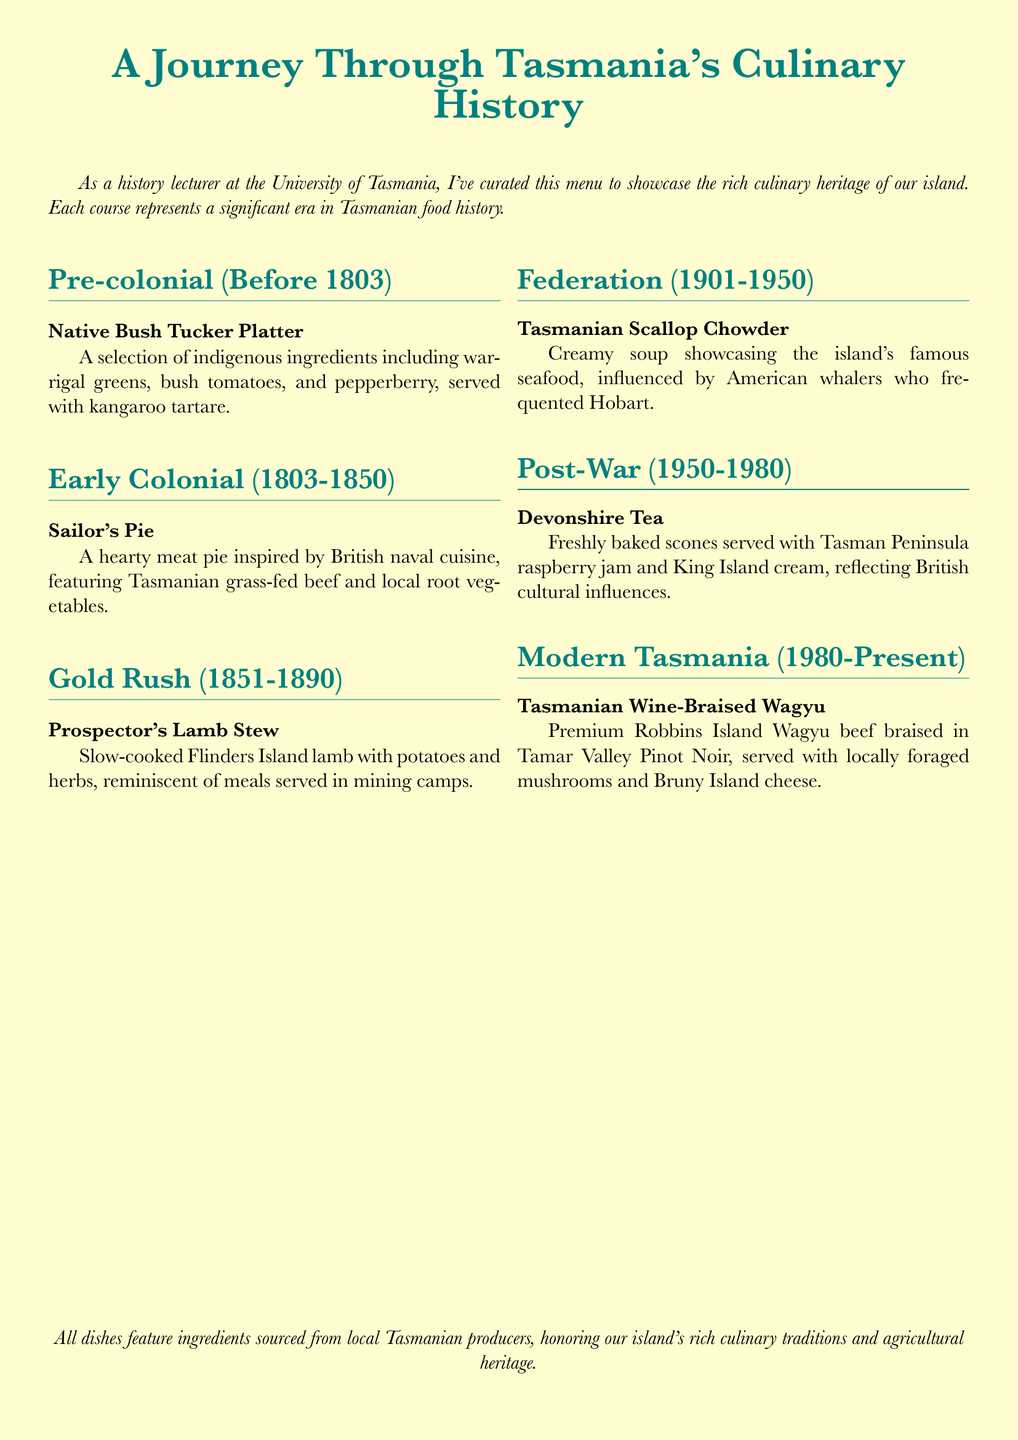What dish represents the pre-colonial era? The dish that represents the pre-colonial era is a selection of indigenous ingredients, highlighting the cultural roots and food traditions.
Answer: Native Bush Tucker Platter What main ingredient is used in the Sailor's Pie? The primary ingredient featured in the Sailor's Pie is a type of meat that reflects British naval traditions.
Answer: Tasmanian grass-fed beef Which dish is associated with the Gold Rush period? The dish associated with the Gold Rush period reflects the mining camp settings and available ingredients during that time.
Answer: Prospector's Lamb Stew What era does the Devonshire Tea belong to? Devonshire Tea is connected to a specific period in Tasmanian cuisine that reflects British cultural influence.
Answer: Post-War (1950-1980) Which ingredient is highlighted in the Tasmanian Scallop Chowder? A specific type of seafood is emphasized in the Tasmanian Scallop Chowder, showcasing local culinary resources.
Answer: Scallops What is the serving style of the Modern Tasmania dish? The serving style of this dish reflects contemporary culinary trends, often associated with premium ingredients and wine pairings.
Answer: Braised in Tamar Valley Pinot Noir What cultural influence is observed in the Post-War dish? The Post-War dish reflects the influence of a specific country and their culinary contributions to Tasmanian cuisine.
Answer: British What type of cuisine does the menu focus on? The menu showcases a specific regional cuisine that has evolved over time on an island, maintaining a unique heritage.
Answer: Tasmanian cuisine 